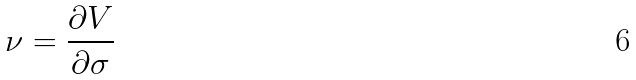<formula> <loc_0><loc_0><loc_500><loc_500>\nu = \frac { \partial V } { \partial \sigma }</formula> 